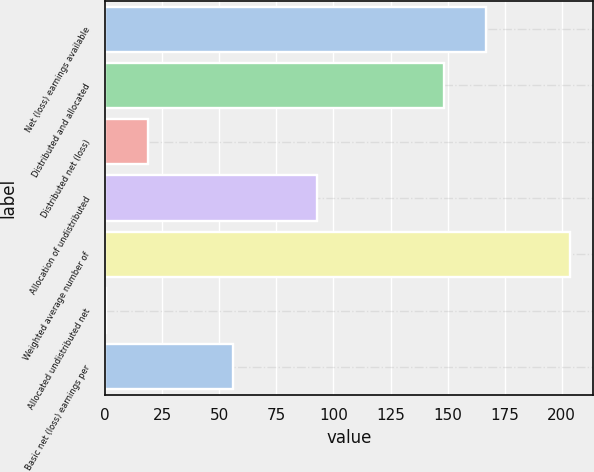Convert chart to OTSL. <chart><loc_0><loc_0><loc_500><loc_500><bar_chart><fcel>Net (loss) earnings available<fcel>Distributed and allocated<fcel>Distributed net (loss)<fcel>Allocation of undistributed<fcel>Weighted average number of<fcel>Allocated undistributed net<fcel>Basic net (loss) earnings per<nl><fcel>166.7<fcel>148.2<fcel>18.87<fcel>92.87<fcel>203.7<fcel>0.37<fcel>55.87<nl></chart> 